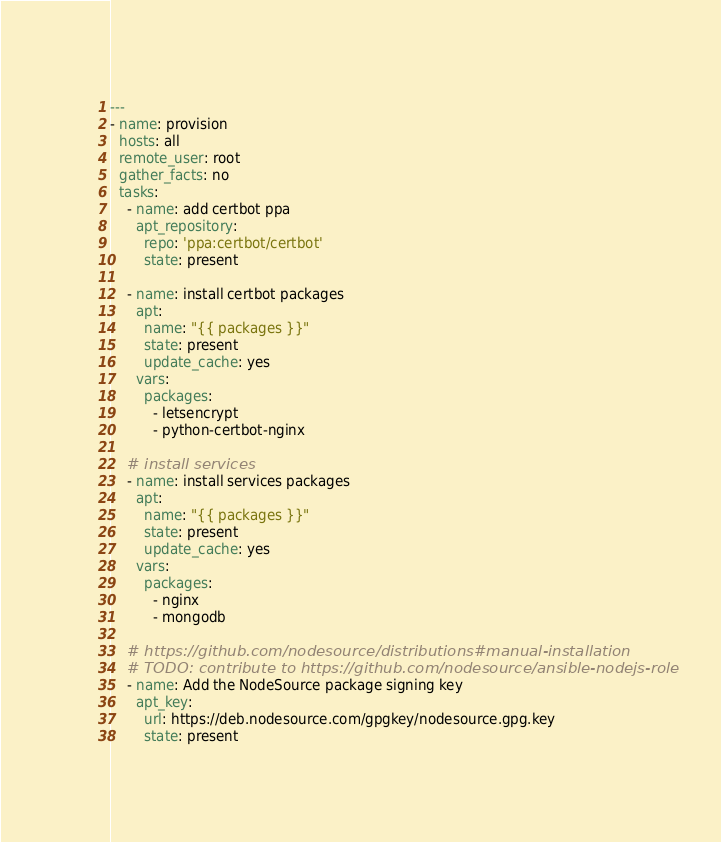<code> <loc_0><loc_0><loc_500><loc_500><_YAML_>---
- name: provision
  hosts: all
  remote_user: root
  gather_facts: no
  tasks:
    - name: add certbot ppa
      apt_repository:
        repo: 'ppa:certbot/certbot'
        state: present

    - name: install certbot packages
      apt:
        name: "{{ packages }}"
        state: present
        update_cache: yes
      vars:
        packages:
          - letsencrypt
          - python-certbot-nginx

    # install services
    - name: install services packages
      apt:
        name: "{{ packages }}"
        state: present
        update_cache: yes
      vars:
        packages:
          - nginx
          - mongodb

    # https://github.com/nodesource/distributions#manual-installation
    # TODO: contribute to https://github.com/nodesource/ansible-nodejs-role
    - name: Add the NodeSource package signing key
      apt_key:
        url: https://deb.nodesource.com/gpgkey/nodesource.gpg.key
        state: present</code> 